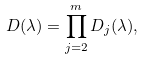Convert formula to latex. <formula><loc_0><loc_0><loc_500><loc_500>D ( \lambda ) = \prod _ { j = 2 } ^ { m } D _ { j } ( \lambda ) ,</formula> 